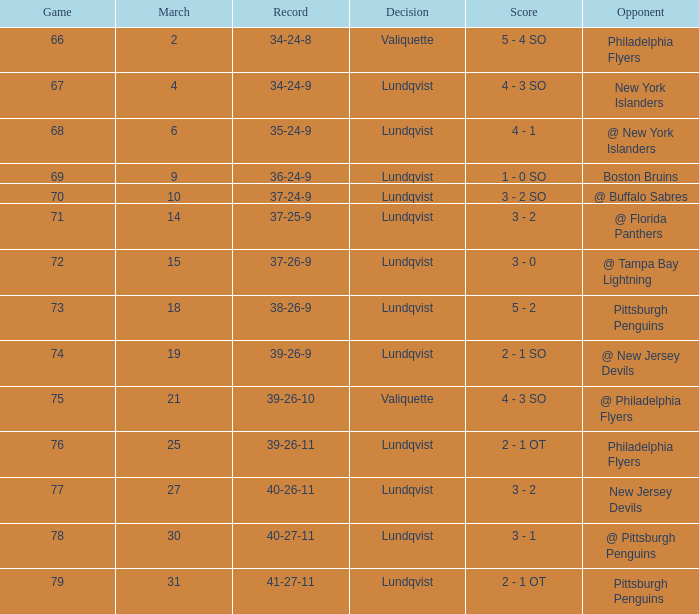Which opponent's game was less than 76 when the march was 10? @ Buffalo Sabres. 